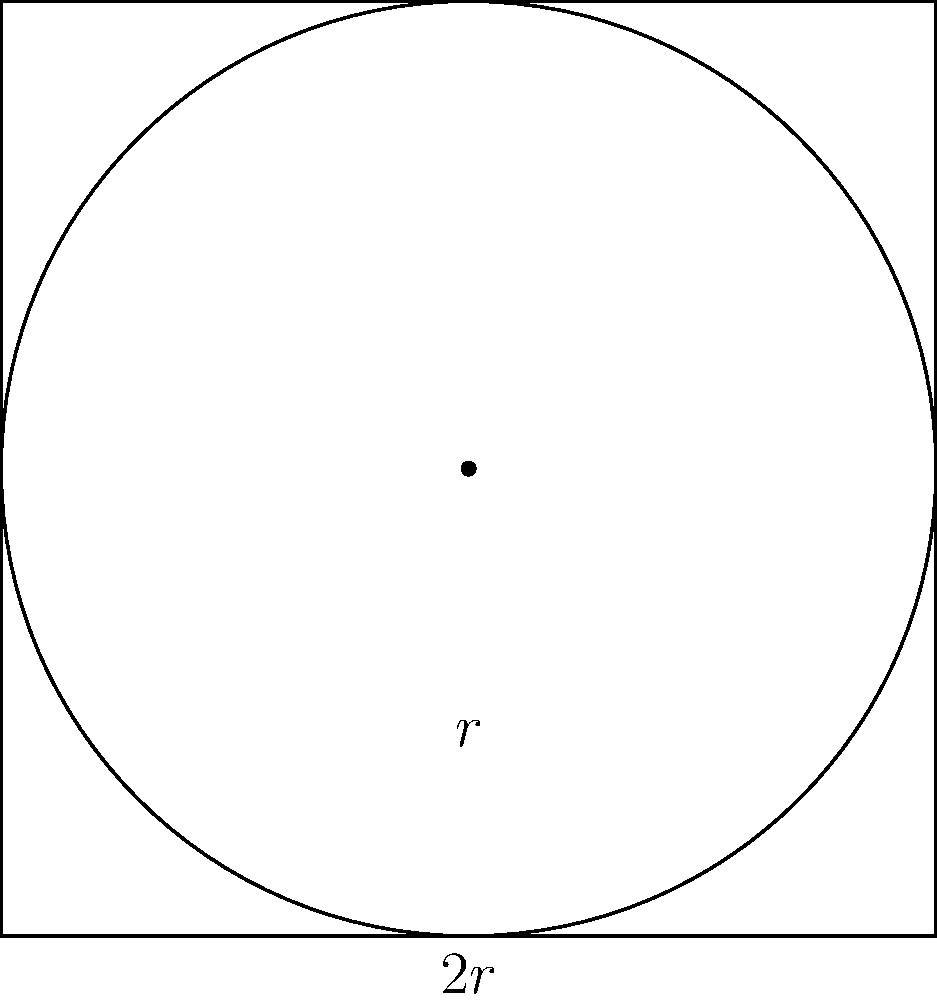In a legal dispute over property boundaries, you encounter a case involving a circular pool inscribed within a square plot of land. The side length of the square plot is 40 feet. What is the area of the circular pool in square feet? Round your answer to the nearest whole number. Let's approach this step-by-step:

1) First, we need to find the radius of the inscribed circle. In a square with an inscribed circle, the diameter of the circle is equal to the side length of the square.

2) Let the radius of the circle be $r$. Then the diameter is $2r$, which is equal to the side of the square.

   $2r = 40$ feet

3) Solving for $r$:
   
   $r = 20$ feet

4) Now that we have the radius, we can calculate the area of the circle using the formula:

   $A = \pi r^2$

5) Substituting our value for $r$:

   $A = \pi (20)^2 = 400\pi$ square feet

6) Using $\pi \approx 3.14159$:

   $A \approx 400 * 3.14159 = 1256.636$ square feet

7) Rounding to the nearest whole number:

   $A \approx 1257$ square feet
Answer: 1257 square feet 